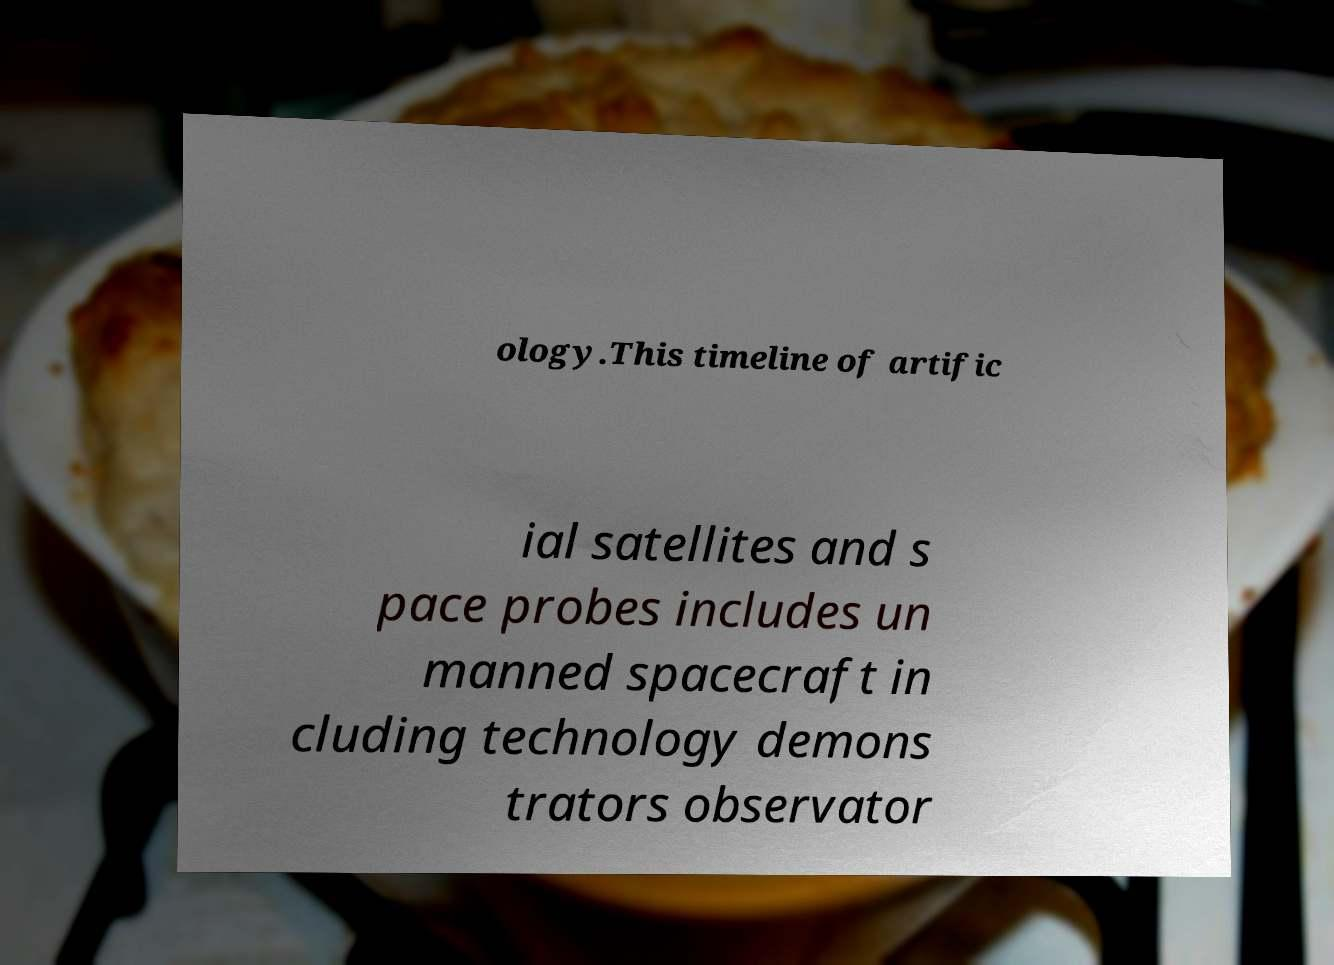Can you accurately transcribe the text from the provided image for me? ology.This timeline of artific ial satellites and s pace probes includes un manned spacecraft in cluding technology demons trators observator 